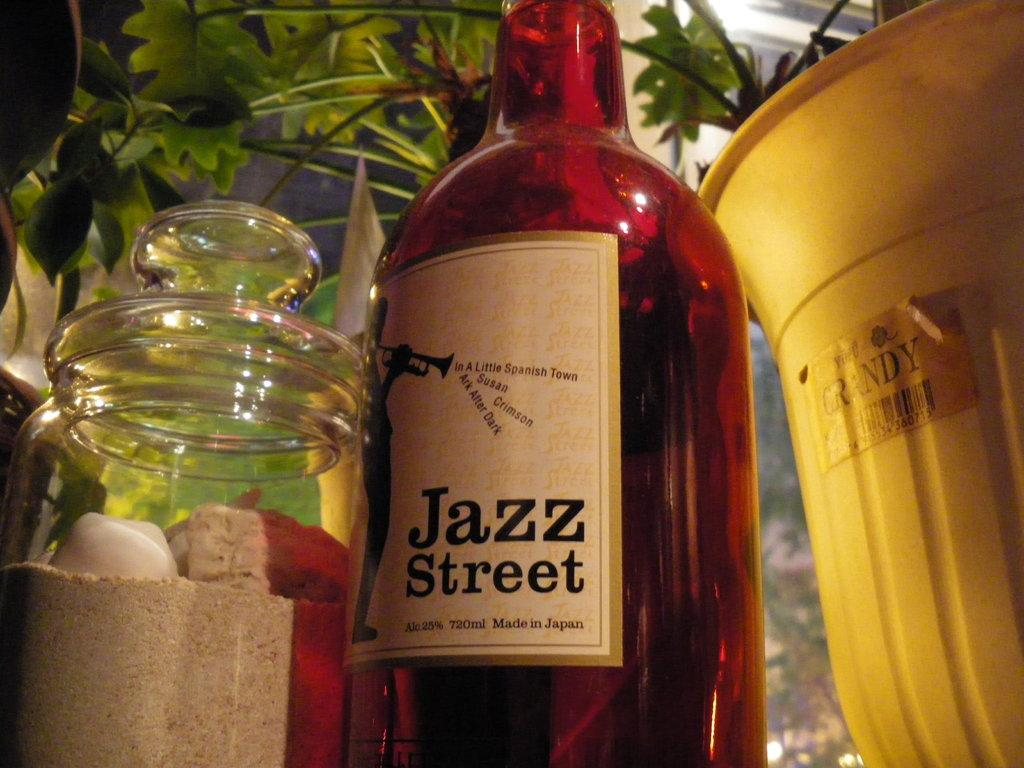Provide a one-sentence caption for the provided image. A brown bottle of Jazz Street is next to a yellow bucket. 